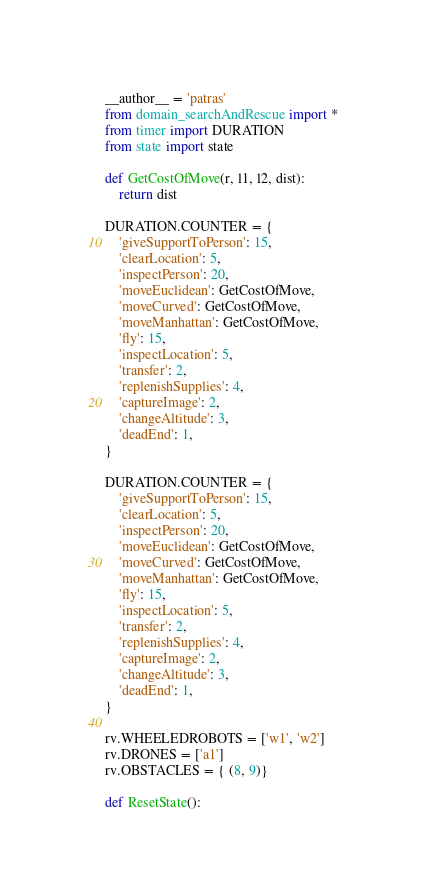<code> <loc_0><loc_0><loc_500><loc_500><_Python_>__author__ = 'patras'
from domain_searchAndRescue import *
from timer import DURATION
from state import state

def GetCostOfMove(r, l1, l2, dist):
    return dist

DURATION.COUNTER = {
    'giveSupportToPerson': 15,
    'clearLocation': 5,
    'inspectPerson': 20,
    'moveEuclidean': GetCostOfMove,
    'moveCurved': GetCostOfMove,
    'moveManhattan': GetCostOfMove,
    'fly': 15,
    'inspectLocation': 5,
    'transfer': 2,
    'replenishSupplies': 4,
    'captureImage': 2,
    'changeAltitude': 3,
    'deadEnd': 1,
}

DURATION.COUNTER = {
    'giveSupportToPerson': 15,
    'clearLocation': 5,
    'inspectPerson': 20,
    'moveEuclidean': GetCostOfMove,
    'moveCurved': GetCostOfMove,
    'moveManhattan': GetCostOfMove,
    'fly': 15,
    'inspectLocation': 5,
    'transfer': 2,
    'replenishSupplies': 4,
    'captureImage': 2,
    'changeAltitude': 3,
    'deadEnd': 1,
}

rv.WHEELEDROBOTS = ['w1', 'w2']
rv.DRONES = ['a1']
rv.OBSTACLES = { (8, 9)}

def ResetState():</code> 